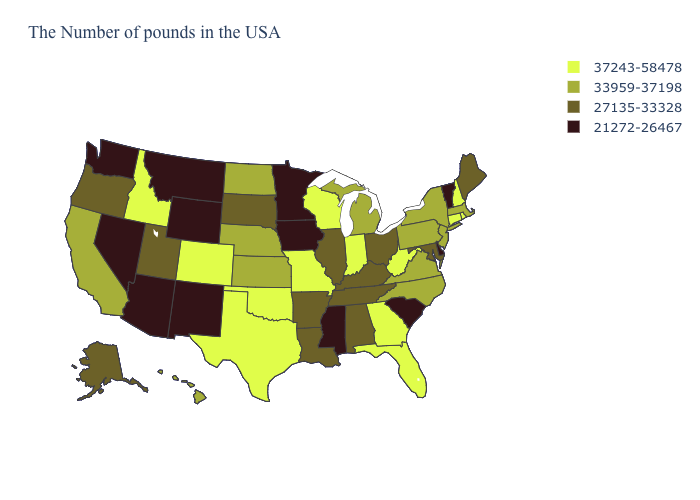Among the states that border Kentucky , which have the highest value?
Be succinct. West Virginia, Indiana, Missouri. What is the value of Wisconsin?
Be succinct. 37243-58478. Among the states that border South Carolina , which have the lowest value?
Be succinct. North Carolina. What is the lowest value in the MidWest?
Short answer required. 21272-26467. Does the first symbol in the legend represent the smallest category?
Concise answer only. No. Does Hawaii have a lower value than Oklahoma?
Quick response, please. Yes. Name the states that have a value in the range 21272-26467?
Give a very brief answer. Vermont, Delaware, South Carolina, Mississippi, Minnesota, Iowa, Wyoming, New Mexico, Montana, Arizona, Nevada, Washington. What is the value of Virginia?
Concise answer only. 33959-37198. What is the value of New Hampshire?
Quick response, please. 37243-58478. Which states have the lowest value in the Northeast?
Give a very brief answer. Vermont. Among the states that border Pennsylvania , does New York have the highest value?
Answer briefly. No. What is the value of New Mexico?
Short answer required. 21272-26467. What is the value of Nebraska?
Keep it brief. 33959-37198. Does Idaho have the highest value in the West?
Concise answer only. Yes. Which states have the lowest value in the Northeast?
Short answer required. Vermont. 